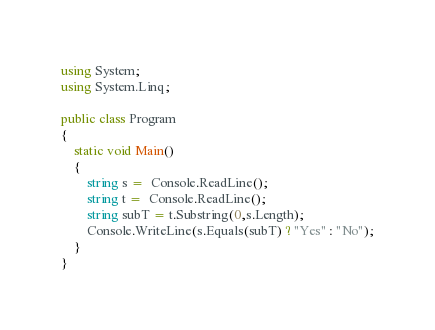<code> <loc_0><loc_0><loc_500><loc_500><_C#_>using System;
using System.Linq;

public class Program
{
    static void Main()
    {
        string s =  Console.ReadLine();
        string t =  Console.ReadLine();
        string subT = t.Substring(0,s.Length);
        Console.WriteLine(s.Equals(subT) ? "Yes" : "No");
    }
}</code> 